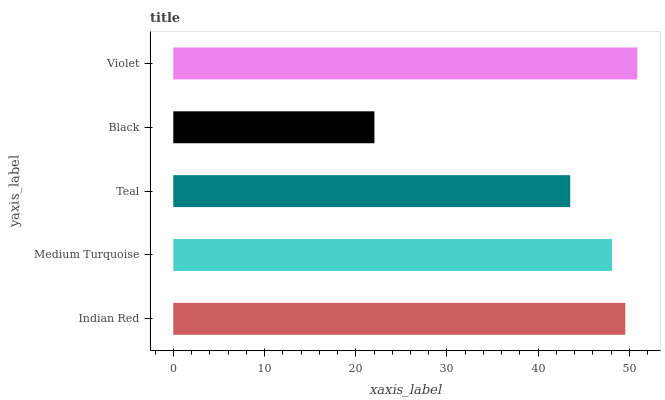Is Black the minimum?
Answer yes or no. Yes. Is Violet the maximum?
Answer yes or no. Yes. Is Medium Turquoise the minimum?
Answer yes or no. No. Is Medium Turquoise the maximum?
Answer yes or no. No. Is Indian Red greater than Medium Turquoise?
Answer yes or no. Yes. Is Medium Turquoise less than Indian Red?
Answer yes or no. Yes. Is Medium Turquoise greater than Indian Red?
Answer yes or no. No. Is Indian Red less than Medium Turquoise?
Answer yes or no. No. Is Medium Turquoise the high median?
Answer yes or no. Yes. Is Medium Turquoise the low median?
Answer yes or no. Yes. Is Violet the high median?
Answer yes or no. No. Is Indian Red the low median?
Answer yes or no. No. 